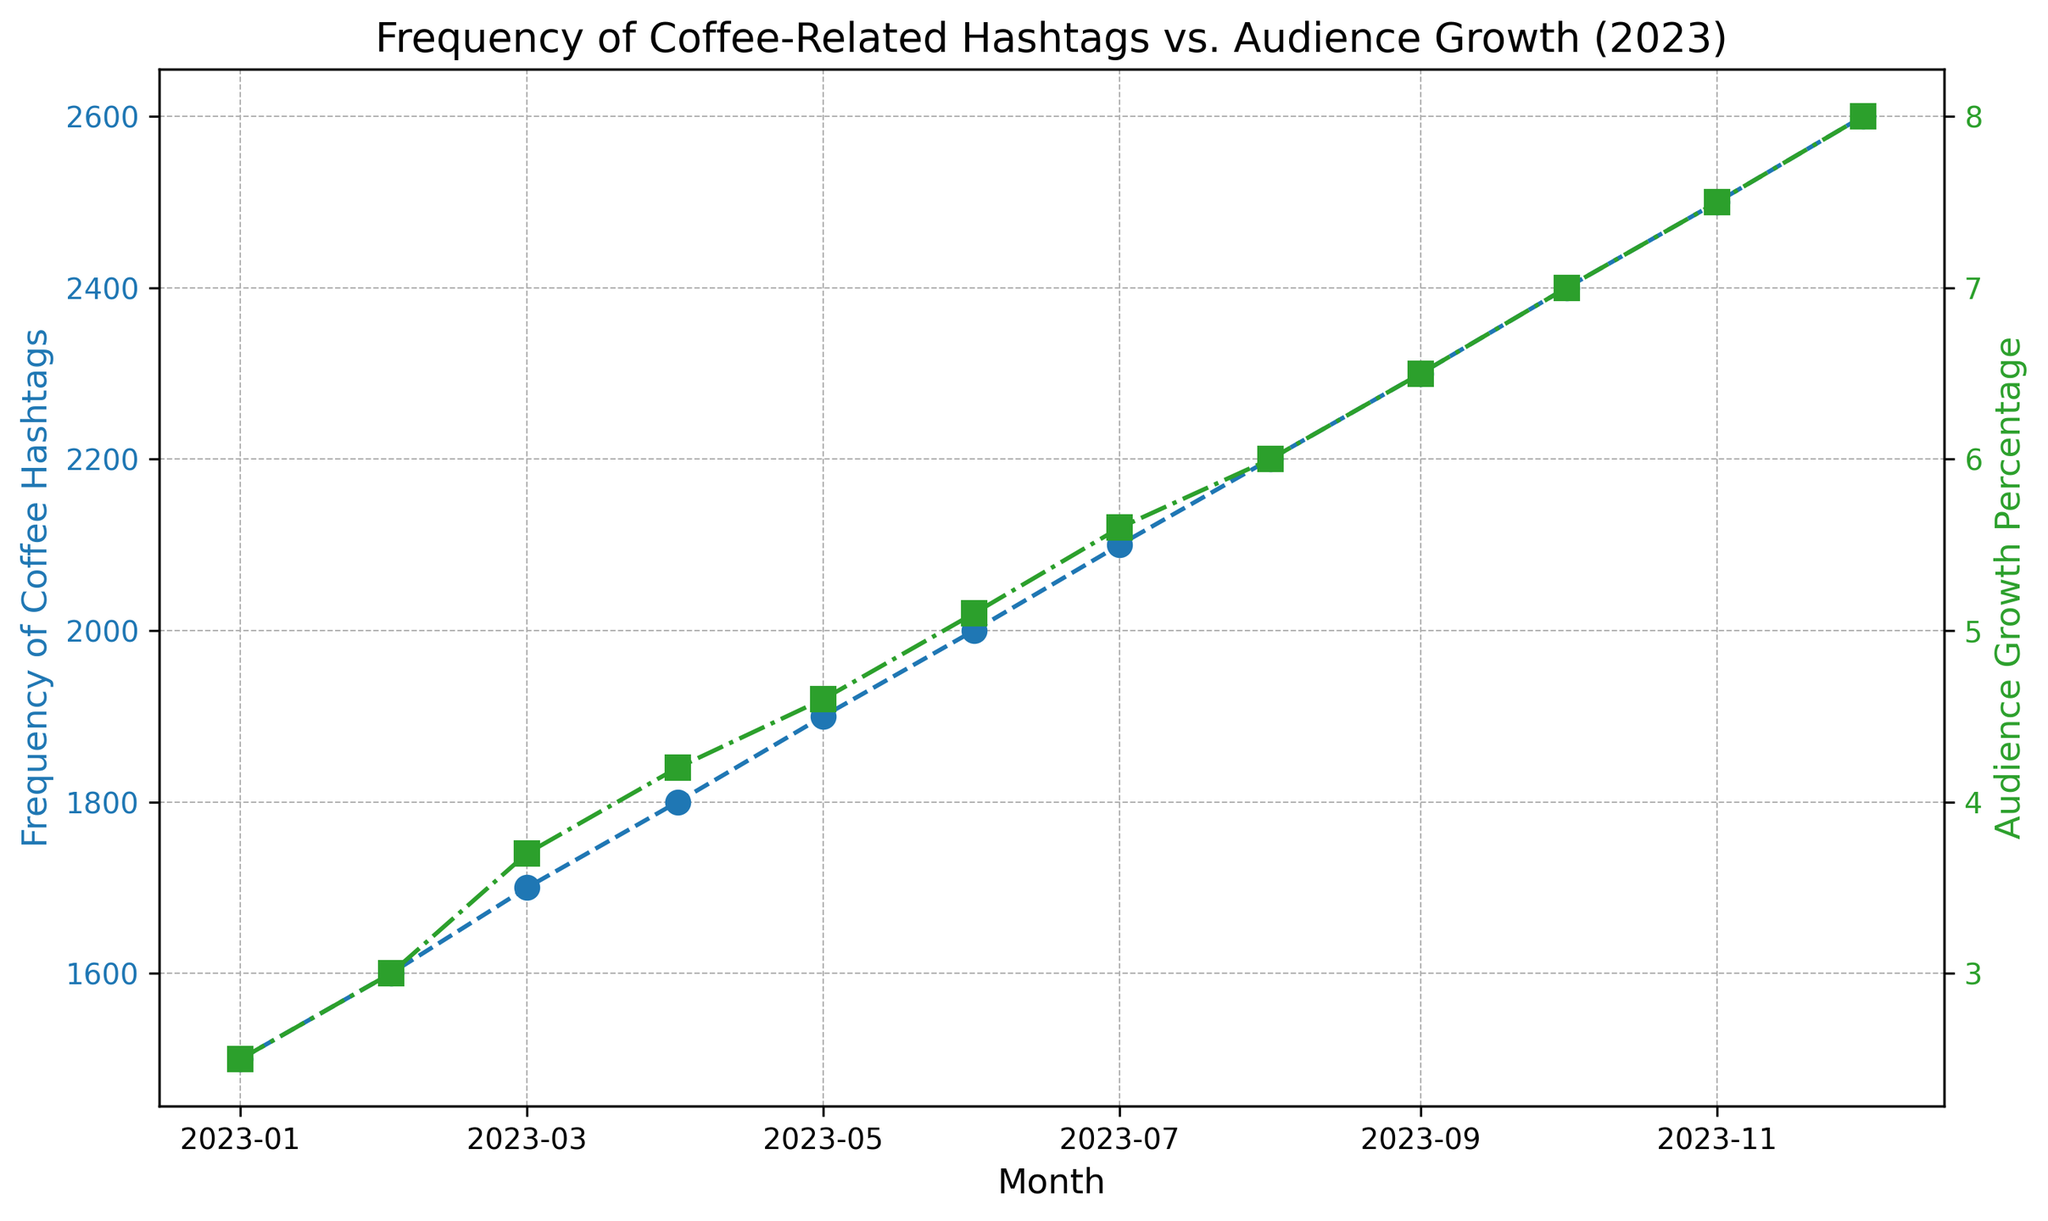Which month had the highest frequency of coffee hashtags? In the figure, look for the highest point on the blue dashed line (Hashtags). The month corresponding to this point is Dec-2023, as it reaches 2600.
Answer: Dec-2023 What is the trend in audience growth from Jan-2023 to Dec-2023? The green dashdot line shows the trend in audience growth percentage. It starts at 2.5% in Jan-2023 and rises steadily to 8.0% in Dec-2023, indicating a continuous growth throughout the year.
Answer: Continuous growth Compare the audience growth percentage in Jul-2023 to May-2023. Which one is higher and by how much? In the figure, Jul-2023 has a green marker at 5.6% and May-2023 has one at 4.6%. Subtract 4.6% from 5.6% to find the difference, which is 1.0%.
Answer: Jul-2023 is higher by 1.0% Is there a positive correlation between the frequency of coffee hashtags and audience growth percentage? Both the blue and green lines show an upward trend throughout the year, indicating that as the frequency of coffee hashtags increases, so does the audience growth percentage.
Answer: Yes, positive correlation What is the average audience growth percentage for the last three months of 2023? Look at the data points for Oct-2023 (7.0%), Nov-2023 (7.5%), and Dec-2023 (8.0%). Add these percentages and divide by 3: (7.0 + 7.5 + 8.0) / 3 = 7.5%.
Answer: 7.5% Which month shows the largest single-month increase in hashtag frequency? Compare the monthly changes in the blue dashed line. The biggest increase occurs from one month to the next in terms of the number of hashtags. From Aug-2023 (2200) to Sep-2023 (2300), the increase is 100.
Answer: Aug-2023 to Sep-2023 Between which months does the audience growth percentage first surpass 5%? Examine the green dashdot line. The percentages surpass 5% between May-2023 (4.6%) and Jun-2023 (5.1%).
Answer: May-2023 to Jun-2023 What is the frequency of coffee hashtags in Jun-2023 and its corresponding audience growth percentage? In the figure, Jun-2023 shows a blue marker at 2000 hashtags and a green marker at 5.1% audience growth.
Answer: 2000 hashtags and 5.1% growth Does the frequency of coffee hashtags ever decrease month-over-month in 2023? Observe the blue dashed line closely. It shows a consistent upward trend from Jan-2023 to Dec-2023 without any decreases.
Answer: No 